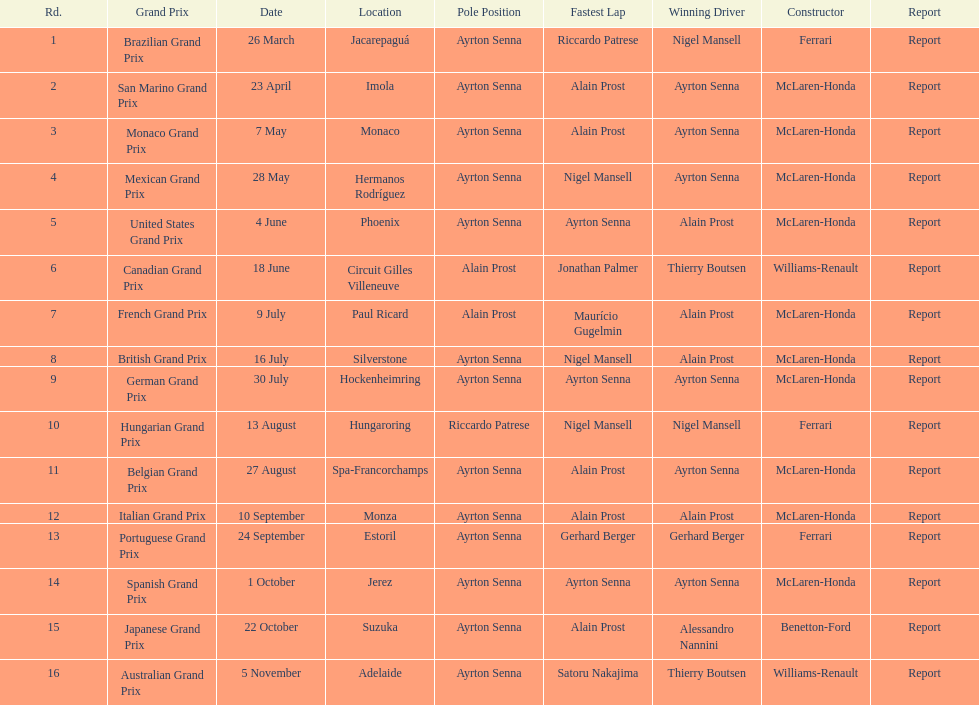How many races occurred before alain prost won a pole position? 5. 